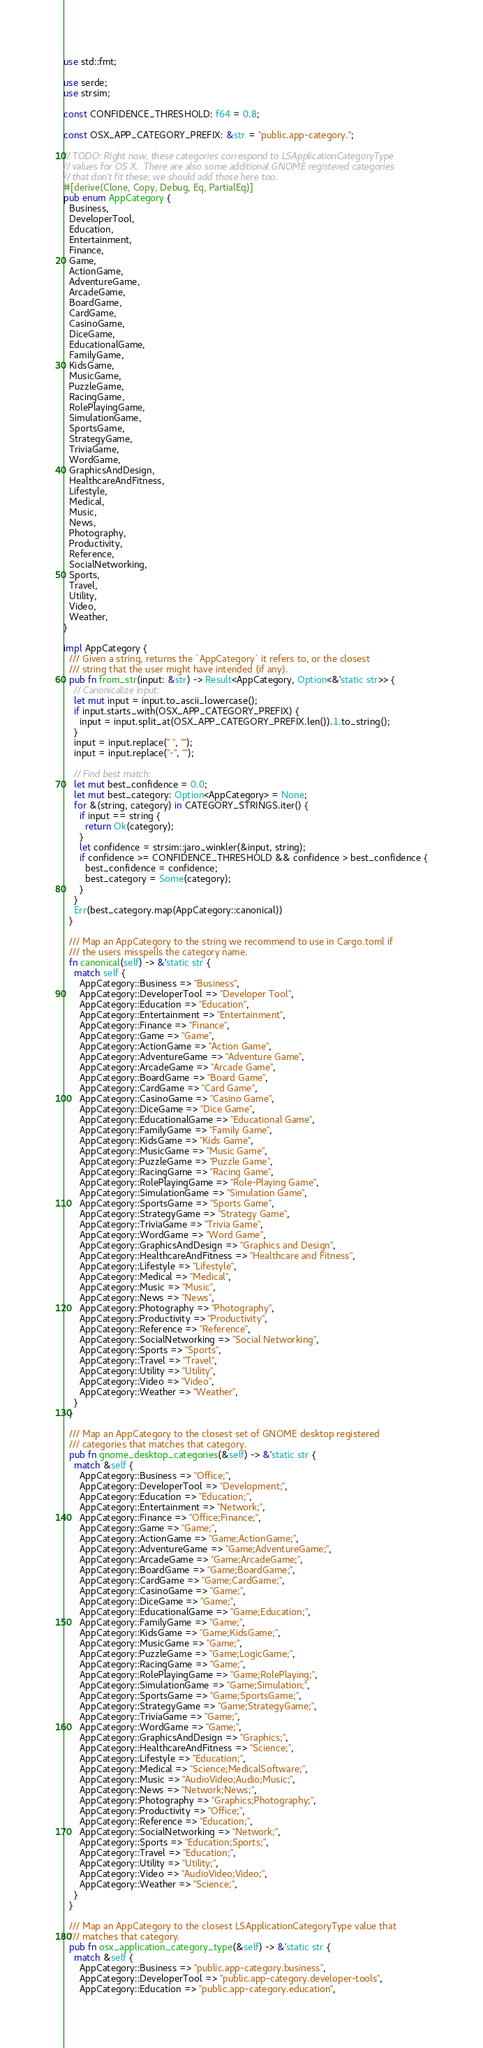Convert code to text. <code><loc_0><loc_0><loc_500><loc_500><_Rust_>use std::fmt;

use serde;
use strsim;

const CONFIDENCE_THRESHOLD: f64 = 0.8;

const OSX_APP_CATEGORY_PREFIX: &str = "public.app-category.";

// TODO: RIght now, these categories correspond to LSApplicationCategoryType
// values for OS X.  There are also some additional GNOME registered categories
// that don't fit these; we should add those here too.
#[derive(Clone, Copy, Debug, Eq, PartialEq)]
pub enum AppCategory {
  Business,
  DeveloperTool,
  Education,
  Entertainment,
  Finance,
  Game,
  ActionGame,
  AdventureGame,
  ArcadeGame,
  BoardGame,
  CardGame,
  CasinoGame,
  DiceGame,
  EducationalGame,
  FamilyGame,
  KidsGame,
  MusicGame,
  PuzzleGame,
  RacingGame,
  RolePlayingGame,
  SimulationGame,
  SportsGame,
  StrategyGame,
  TriviaGame,
  WordGame,
  GraphicsAndDesign,
  HealthcareAndFitness,
  Lifestyle,
  Medical,
  Music,
  News,
  Photography,
  Productivity,
  Reference,
  SocialNetworking,
  Sports,
  Travel,
  Utility,
  Video,
  Weather,
}

impl AppCategory {
  /// Given a string, returns the `AppCategory` it refers to, or the closest
  /// string that the user might have intended (if any).
  pub fn from_str(input: &str) -> Result<AppCategory, Option<&'static str>> {
    // Canonicalize input:
    let mut input = input.to_ascii_lowercase();
    if input.starts_with(OSX_APP_CATEGORY_PREFIX) {
      input = input.split_at(OSX_APP_CATEGORY_PREFIX.len()).1.to_string();
    }
    input = input.replace(" ", "");
    input = input.replace("-", "");

    // Find best match:
    let mut best_confidence = 0.0;
    let mut best_category: Option<AppCategory> = None;
    for &(string, category) in CATEGORY_STRINGS.iter() {
      if input == string {
        return Ok(category);
      }
      let confidence = strsim::jaro_winkler(&input, string);
      if confidence >= CONFIDENCE_THRESHOLD && confidence > best_confidence {
        best_confidence = confidence;
        best_category = Some(category);
      }
    }
    Err(best_category.map(AppCategory::canonical))
  }

  /// Map an AppCategory to the string we recommend to use in Cargo.toml if
  /// the users misspells the category name.
  fn canonical(self) -> &'static str {
    match self {
      AppCategory::Business => "Business",
      AppCategory::DeveloperTool => "Developer Tool",
      AppCategory::Education => "Education",
      AppCategory::Entertainment => "Entertainment",
      AppCategory::Finance => "Finance",
      AppCategory::Game => "Game",
      AppCategory::ActionGame => "Action Game",
      AppCategory::AdventureGame => "Adventure Game",
      AppCategory::ArcadeGame => "Arcade Game",
      AppCategory::BoardGame => "Board Game",
      AppCategory::CardGame => "Card Game",
      AppCategory::CasinoGame => "Casino Game",
      AppCategory::DiceGame => "Dice Game",
      AppCategory::EducationalGame => "Educational Game",
      AppCategory::FamilyGame => "Family Game",
      AppCategory::KidsGame => "Kids Game",
      AppCategory::MusicGame => "Music Game",
      AppCategory::PuzzleGame => "Puzzle Game",
      AppCategory::RacingGame => "Racing Game",
      AppCategory::RolePlayingGame => "Role-Playing Game",
      AppCategory::SimulationGame => "Simulation Game",
      AppCategory::SportsGame => "Sports Game",
      AppCategory::StrategyGame => "Strategy Game",
      AppCategory::TriviaGame => "Trivia Game",
      AppCategory::WordGame => "Word Game",
      AppCategory::GraphicsAndDesign => "Graphics and Design",
      AppCategory::HealthcareAndFitness => "Healthcare and Fitness",
      AppCategory::Lifestyle => "Lifestyle",
      AppCategory::Medical => "Medical",
      AppCategory::Music => "Music",
      AppCategory::News => "News",
      AppCategory::Photography => "Photography",
      AppCategory::Productivity => "Productivity",
      AppCategory::Reference => "Reference",
      AppCategory::SocialNetworking => "Social Networking",
      AppCategory::Sports => "Sports",
      AppCategory::Travel => "Travel",
      AppCategory::Utility => "Utility",
      AppCategory::Video => "Video",
      AppCategory::Weather => "Weather",
    }
  }

  /// Map an AppCategory to the closest set of GNOME desktop registered
  /// categories that matches that category.
  pub fn gnome_desktop_categories(&self) -> &'static str {
    match &self {
      AppCategory::Business => "Office;",
      AppCategory::DeveloperTool => "Development;",
      AppCategory::Education => "Education;",
      AppCategory::Entertainment => "Network;",
      AppCategory::Finance => "Office;Finance;",
      AppCategory::Game => "Game;",
      AppCategory::ActionGame => "Game;ActionGame;",
      AppCategory::AdventureGame => "Game;AdventureGame;",
      AppCategory::ArcadeGame => "Game;ArcadeGame;",
      AppCategory::BoardGame => "Game;BoardGame;",
      AppCategory::CardGame => "Game;CardGame;",
      AppCategory::CasinoGame => "Game;",
      AppCategory::DiceGame => "Game;",
      AppCategory::EducationalGame => "Game;Education;",
      AppCategory::FamilyGame => "Game;",
      AppCategory::KidsGame => "Game;KidsGame;",
      AppCategory::MusicGame => "Game;",
      AppCategory::PuzzleGame => "Game;LogicGame;",
      AppCategory::RacingGame => "Game;",
      AppCategory::RolePlayingGame => "Game;RolePlaying;",
      AppCategory::SimulationGame => "Game;Simulation;",
      AppCategory::SportsGame => "Game;SportsGame;",
      AppCategory::StrategyGame => "Game;StrategyGame;",
      AppCategory::TriviaGame => "Game;",
      AppCategory::WordGame => "Game;",
      AppCategory::GraphicsAndDesign => "Graphics;",
      AppCategory::HealthcareAndFitness => "Science;",
      AppCategory::Lifestyle => "Education;",
      AppCategory::Medical => "Science;MedicalSoftware;",
      AppCategory::Music => "AudioVideo;Audio;Music;",
      AppCategory::News => "Network;News;",
      AppCategory::Photography => "Graphics;Photography;",
      AppCategory::Productivity => "Office;",
      AppCategory::Reference => "Education;",
      AppCategory::SocialNetworking => "Network;",
      AppCategory::Sports => "Education;Sports;",
      AppCategory::Travel => "Education;",
      AppCategory::Utility => "Utility;",
      AppCategory::Video => "AudioVideo;Video;",
      AppCategory::Weather => "Science;",
    }
  }

  /// Map an AppCategory to the closest LSApplicationCategoryType value that
  /// matches that category.
  pub fn osx_application_category_type(&self) -> &'static str {
    match &self {
      AppCategory::Business => "public.app-category.business",
      AppCategory::DeveloperTool => "public.app-category.developer-tools",
      AppCategory::Education => "public.app-category.education",</code> 